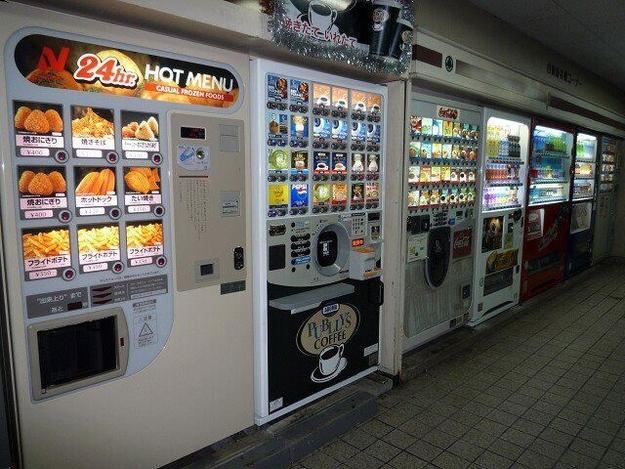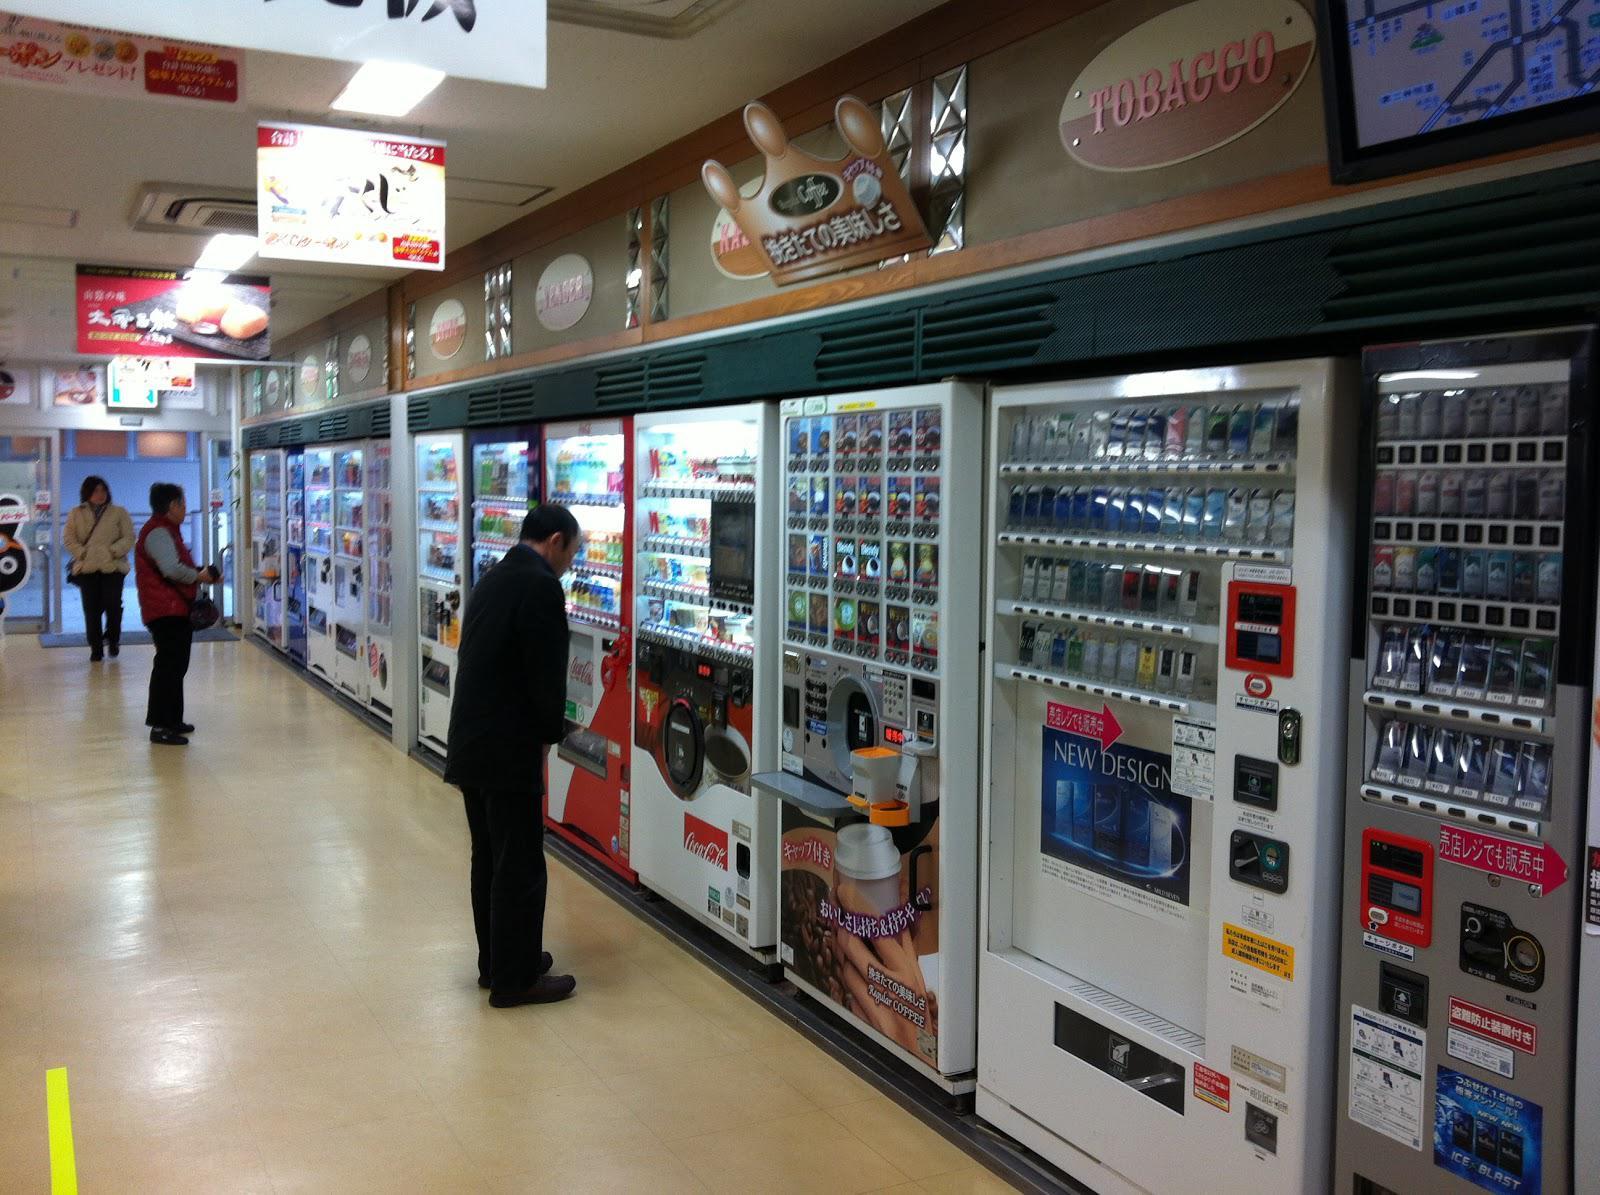The first image is the image on the left, the second image is the image on the right. Analyze the images presented: Is the assertion "There are three beverage vending machines in one of the images." valid? Answer yes or no. No. The first image is the image on the left, the second image is the image on the right. Examine the images to the left and right. Is the description "A trio of vending machines includes at least one red one." accurate? Answer yes or no. No. 